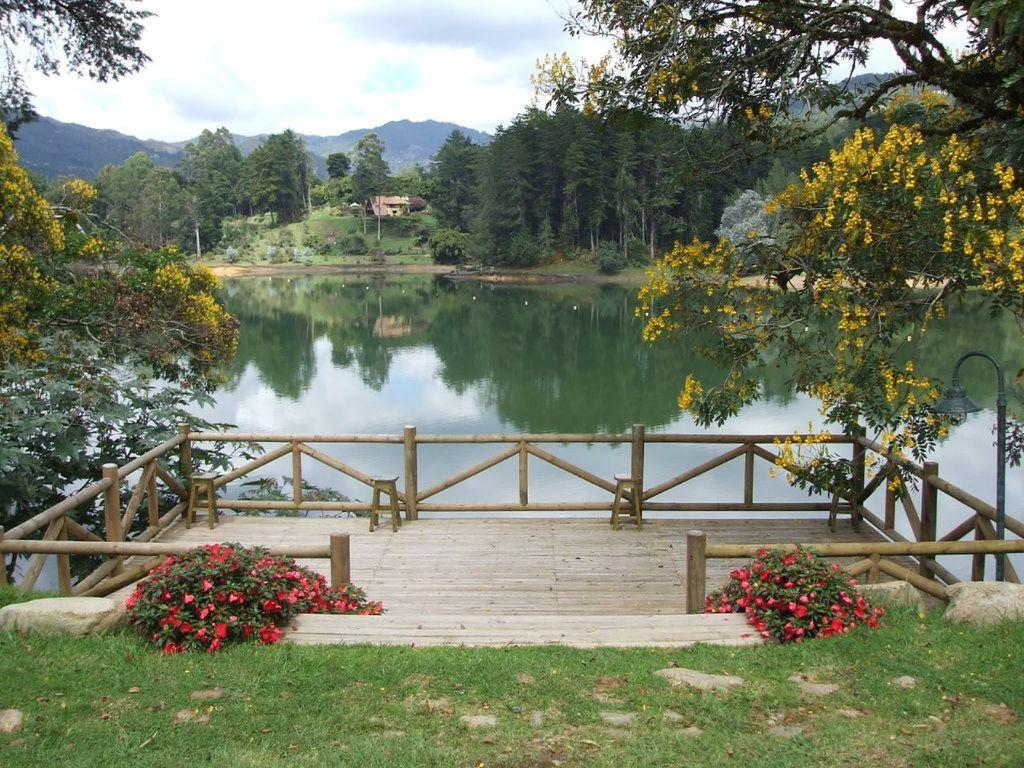What type of vegetation can be seen in the image? There are trees, plants, flowers, and grass visible in the image. What natural element is present in the image? Water is visible in the image. What geographical feature can be seen in the image? There are mountains in the image. What architectural structure is present in the image? There is a building in the background of the image. What is visible in the sky in the image? The sky is visible in the background of the image, and there are clouds present. What man-made structure can be seen in the image? There is a railing in the image. How many cows are grazing in the image? There are no cows present in the image. What is the height of the cannon visible in the image? There is no cannon present in the image. 